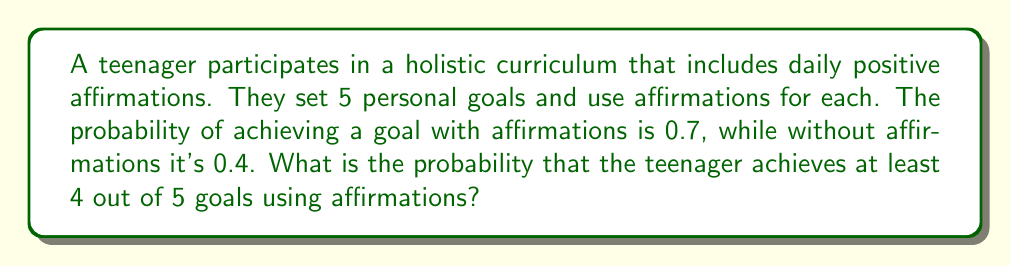What is the answer to this math problem? Let's approach this step-by-step using the binomial probability distribution:

1) We have $n = 5$ trials (goals), and we want the probability of at least $k = 4$ successes.

2) The probability of success for each trial is $p = 0.7$.

3) We need to calculate $P(X \geq 4)$, where $X$ is the number of successes.

4) This is equivalent to $1 - P(X < 4) = 1 - [P(X = 0) + P(X = 1) + P(X = 2) + P(X = 3)]$

5) The binomial probability formula is:

   $$P(X = k) = \binom{n}{k} p^k (1-p)^{n-k}$$

6) Let's calculate each probability:

   $P(X = 5) = \binom{5}{5} 0.7^5 (0.3)^0 = 0.16807$
   
   $P(X = 4) = \binom{5}{4} 0.7^4 (0.3)^1 = 0.36015$

7) The probability of at least 4 successes is:

   $P(X \geq 4) = P(X = 4) + P(X = 5) = 0.36015 + 0.16807 = 0.52822$

Therefore, the probability of achieving at least 4 out of 5 goals using affirmations is approximately 0.52822 or 52.822%.
Answer: 0.52822 